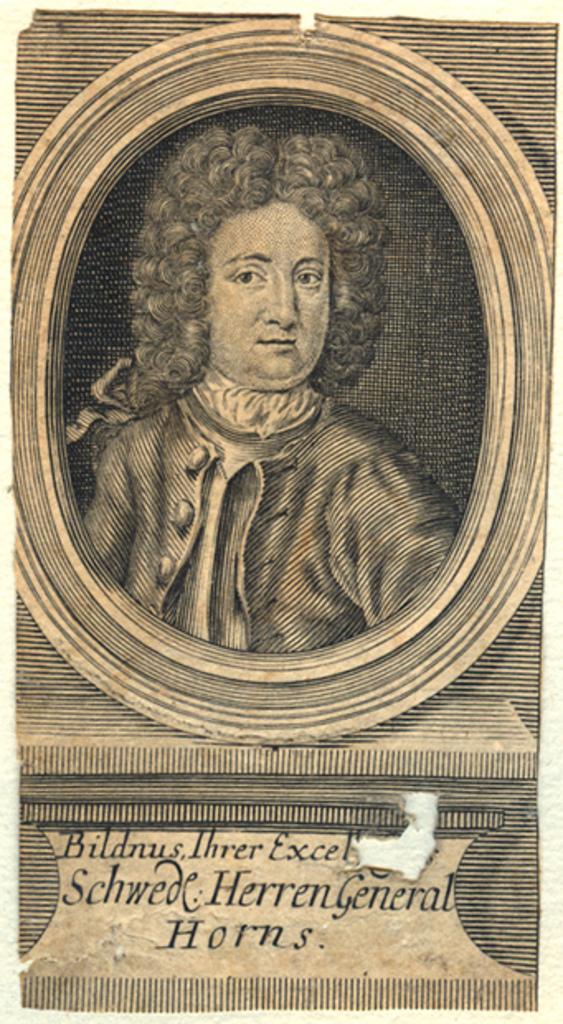What is the last word in the description under the picture?
Make the answer very short. Horns. 